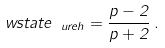<formula> <loc_0><loc_0><loc_500><loc_500>\ w s t a t e _ { \ u r e h } = \frac { p - 2 } { p + 2 } \, .</formula> 